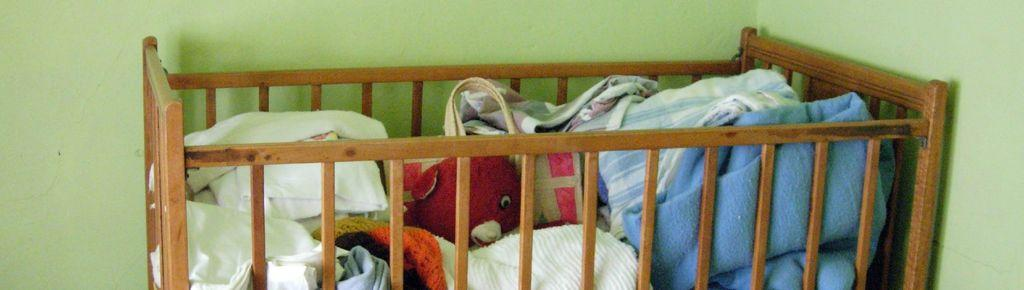What objects are in the foreground of the image? There are pillows, bed sheets, clothes, a bag, and a toy in the foreground of the image. What is the toy's location in the image? The toy is in a baby bed in the foreground of the image. What color is the wall visible in the background of the image? The wall in the background of the image is green. How many yaks can be seen grazing on the land in the image? There are no yaks or land visible in the image; it features a baby bed and other objects in the foreground. What type of chair is present in the image? There is no chair present in the image. 